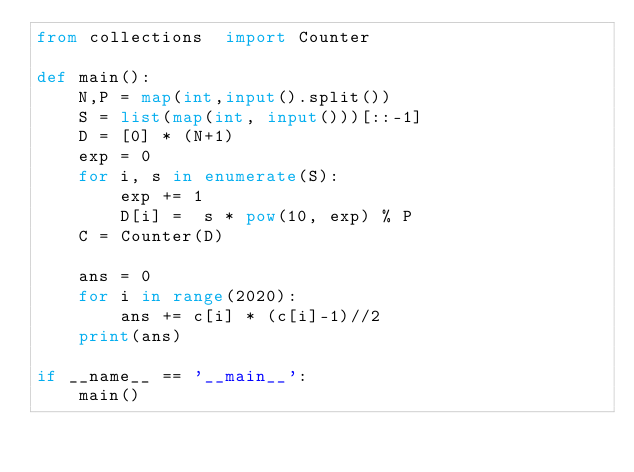Convert code to text. <code><loc_0><loc_0><loc_500><loc_500><_Python_>from collections  import Counter

def main():
    N,P = map(int,input().split())
    S = list(map(int, input()))[::-1]
    D = [0] * (N+1)
    exp = 0
    for i, s in enumerate(S):
        exp += 1
        D[i] =  s * pow(10, exp) % P
    C = Counter(D)

    ans = 0
    for i in range(2020):
        ans += c[i] * (c[i]-1)//2
    print(ans)

if __name__ == '__main__':
    main()</code> 